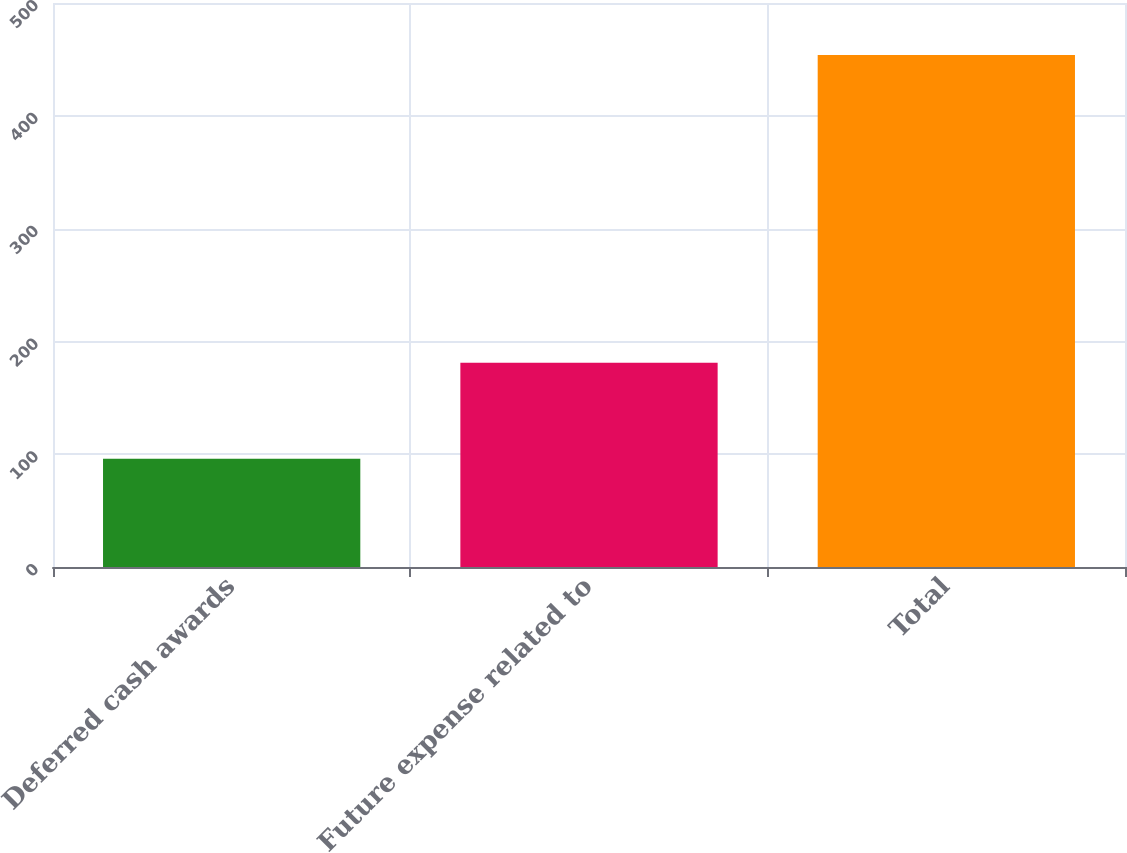Convert chart to OTSL. <chart><loc_0><loc_0><loc_500><loc_500><bar_chart><fcel>Deferred cash awards<fcel>Future expense related to<fcel>Total<nl><fcel>96<fcel>181<fcel>454<nl></chart> 